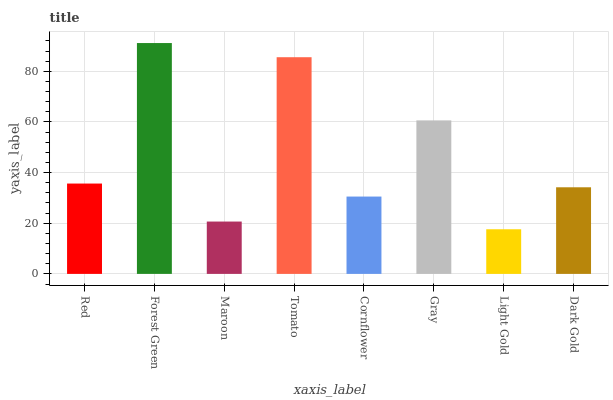Is Maroon the minimum?
Answer yes or no. No. Is Maroon the maximum?
Answer yes or no. No. Is Forest Green greater than Maroon?
Answer yes or no. Yes. Is Maroon less than Forest Green?
Answer yes or no. Yes. Is Maroon greater than Forest Green?
Answer yes or no. No. Is Forest Green less than Maroon?
Answer yes or no. No. Is Red the high median?
Answer yes or no. Yes. Is Dark Gold the low median?
Answer yes or no. Yes. Is Forest Green the high median?
Answer yes or no. No. Is Light Gold the low median?
Answer yes or no. No. 